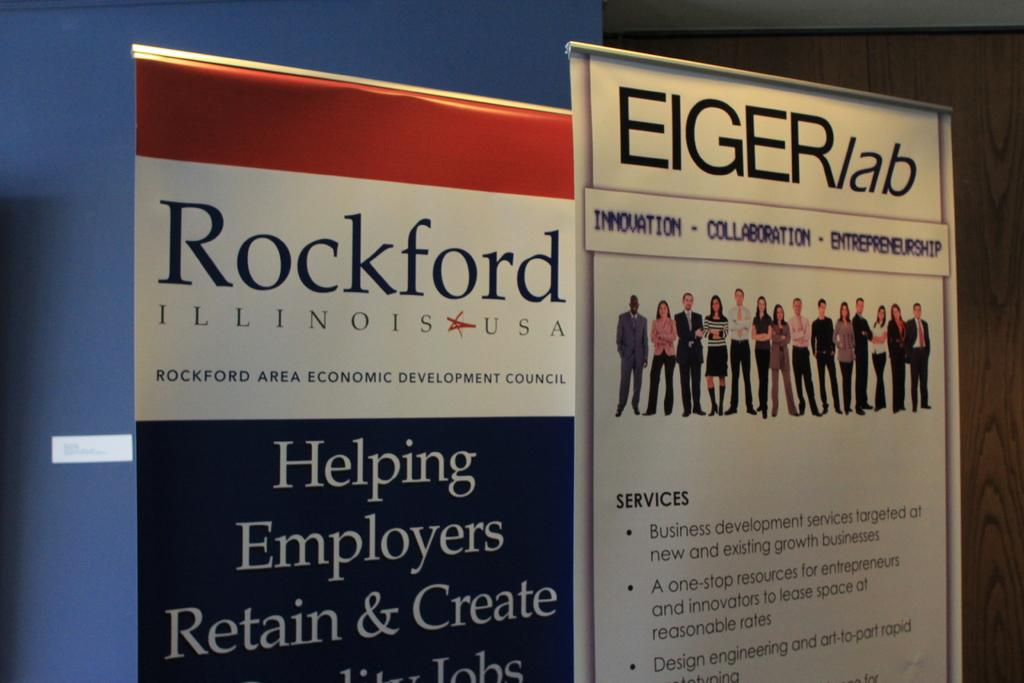<image>
Give a short and clear explanation of the subsequent image. A poster from Rockford area economic development council 